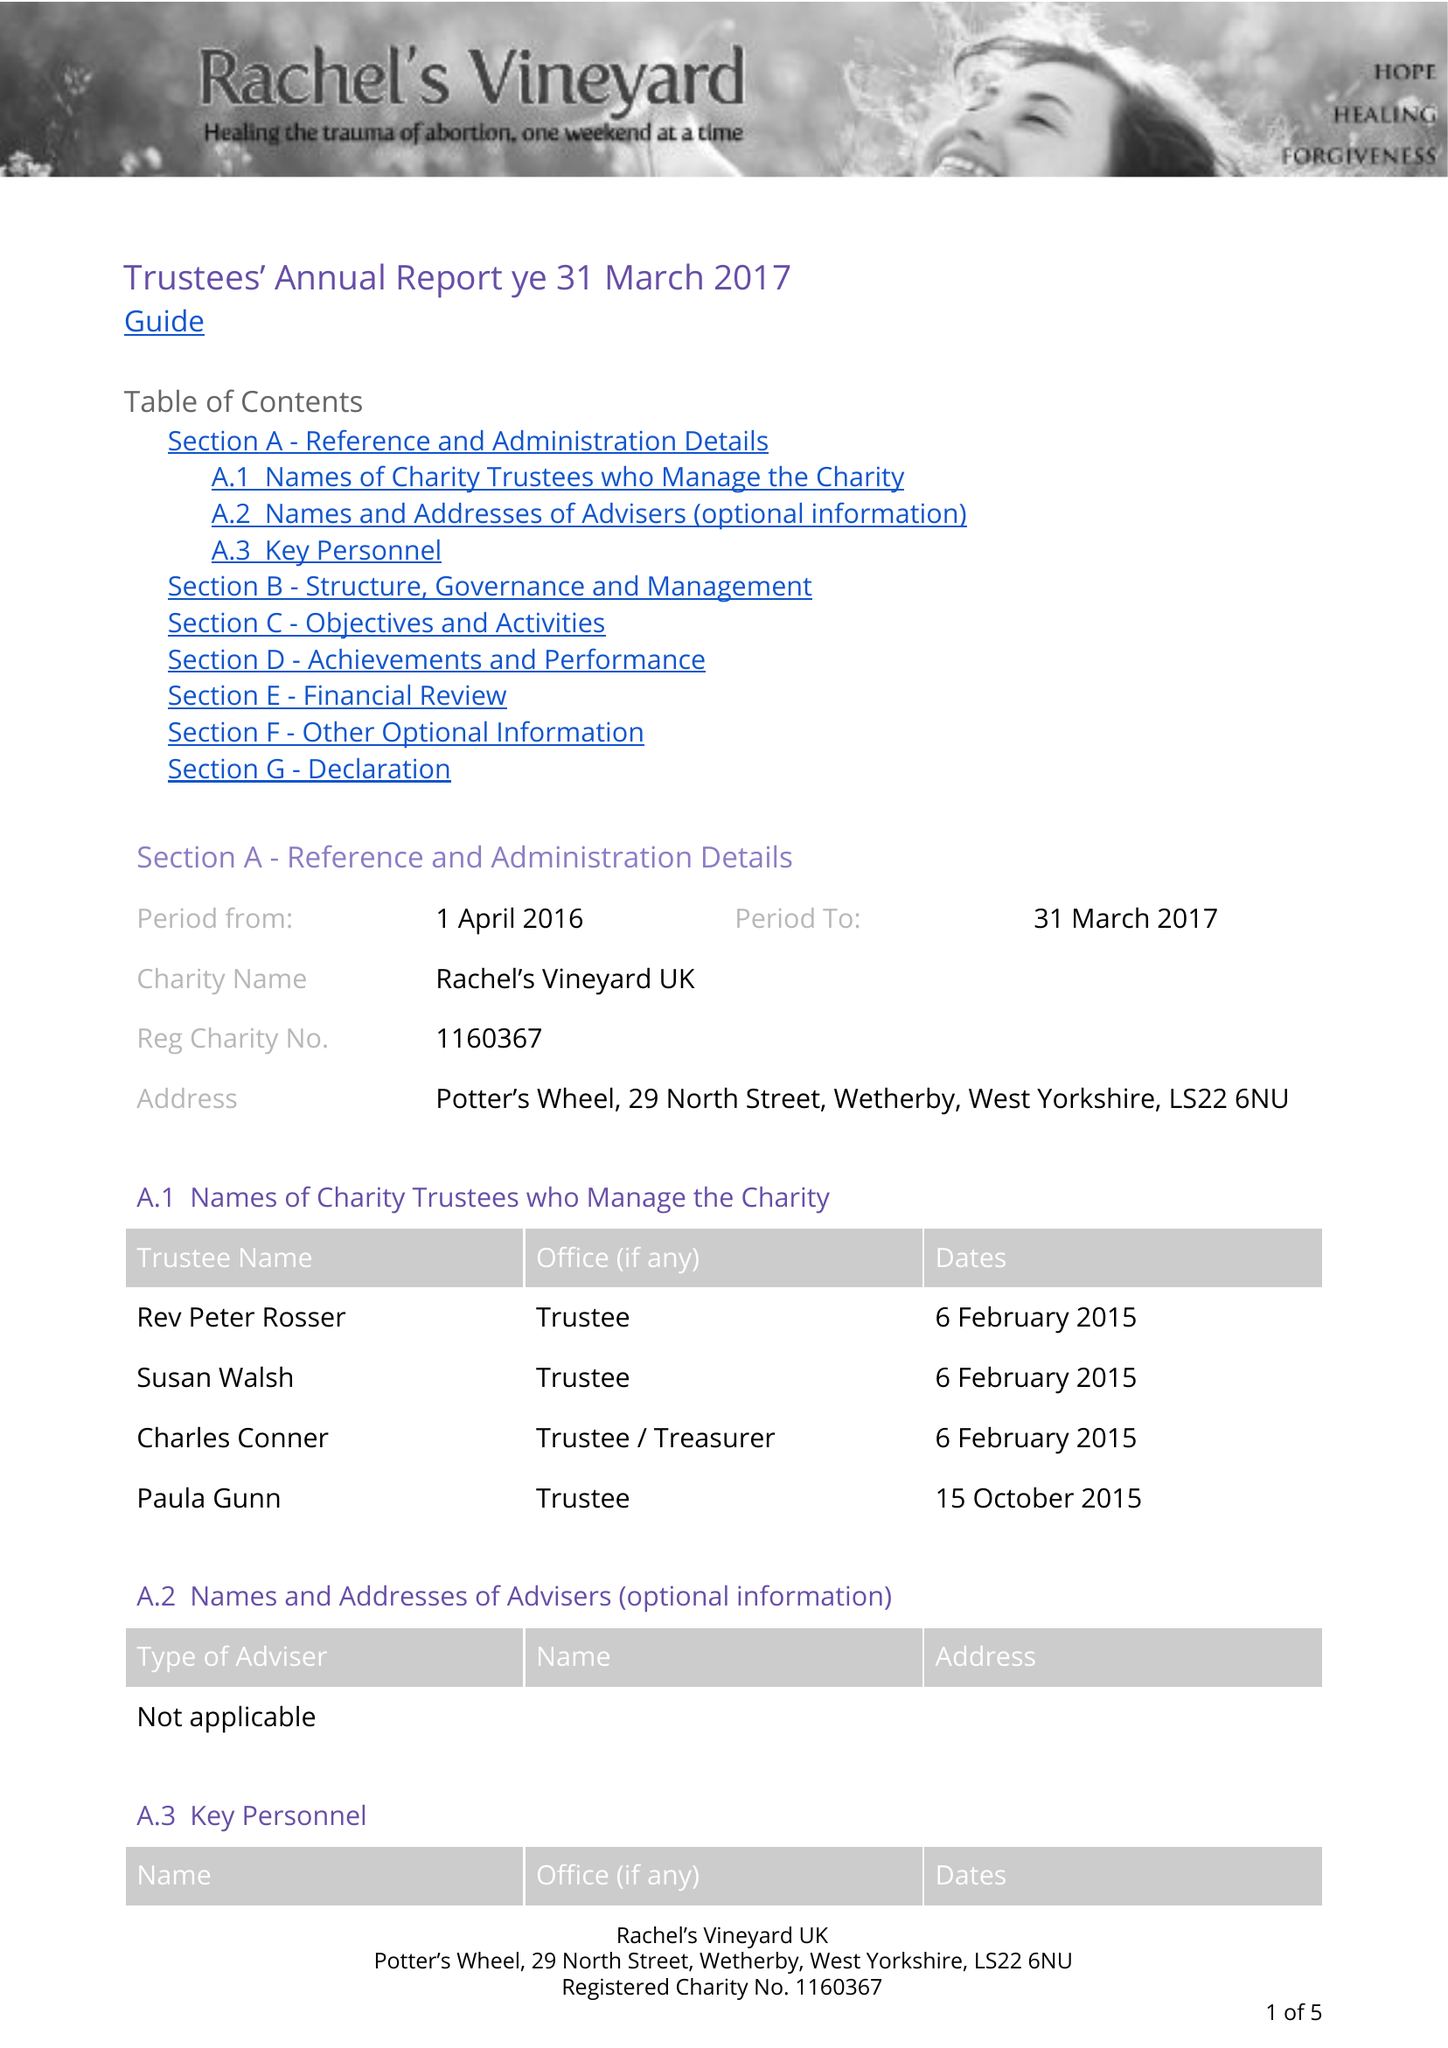What is the value for the income_annually_in_british_pounds?
Answer the question using a single word or phrase. 8036.00 